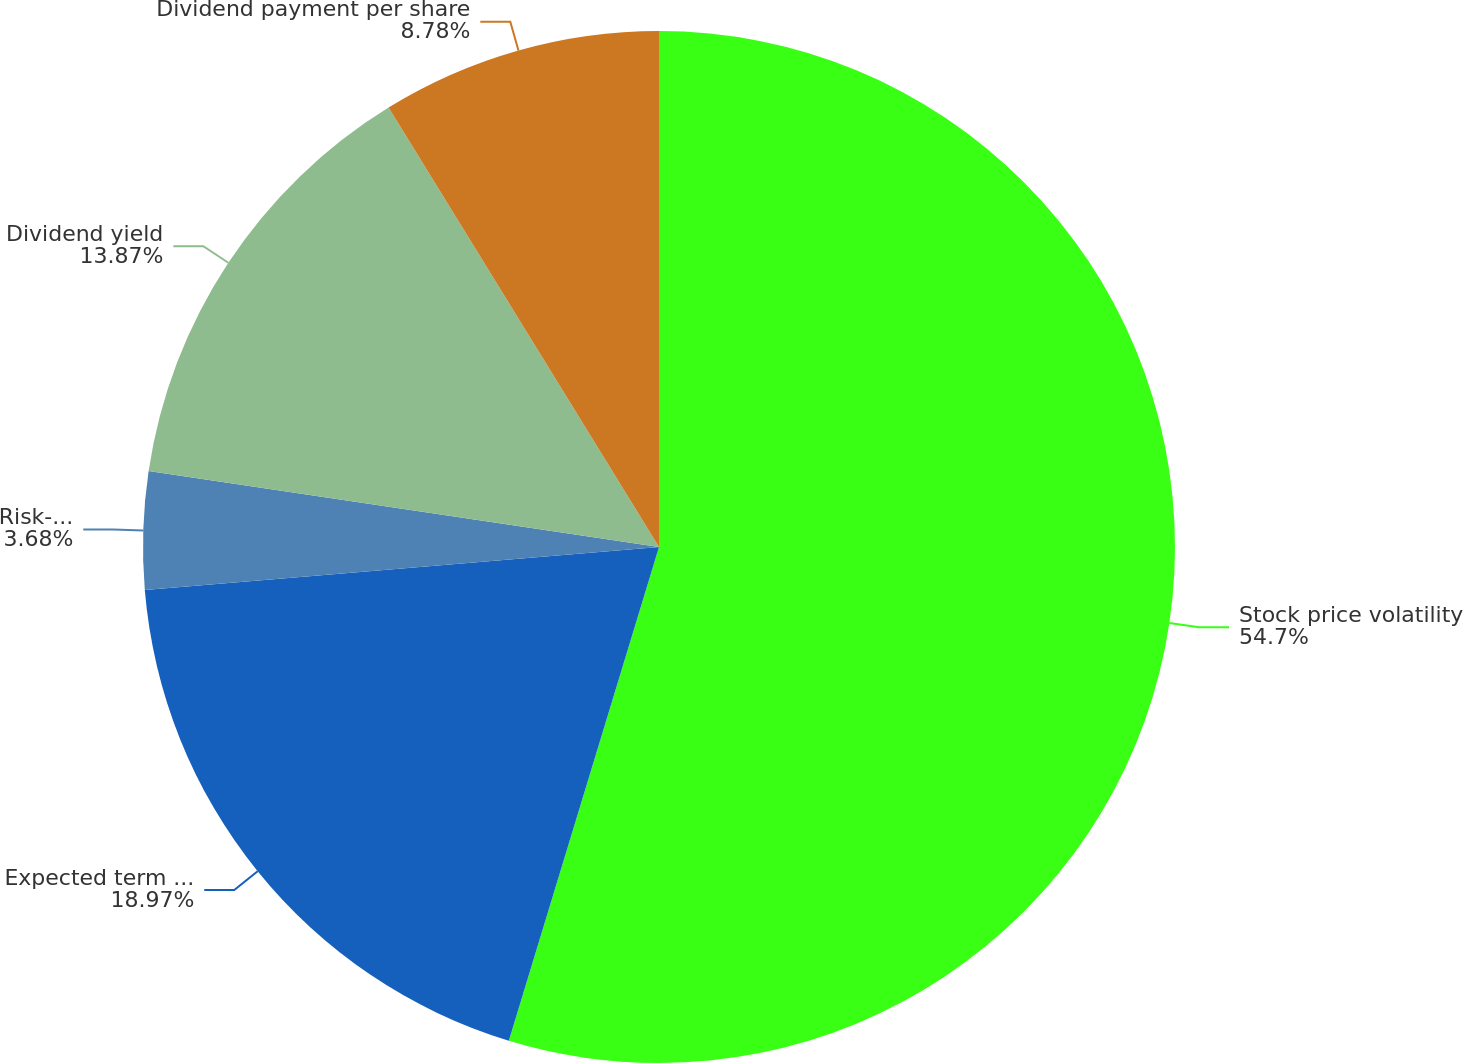Convert chart. <chart><loc_0><loc_0><loc_500><loc_500><pie_chart><fcel>Stock price volatility<fcel>Expected term in years<fcel>Risk-free interest rate<fcel>Dividend yield<fcel>Dividend payment per share<nl><fcel>54.7%<fcel>18.97%<fcel>3.68%<fcel>13.87%<fcel>8.78%<nl></chart> 